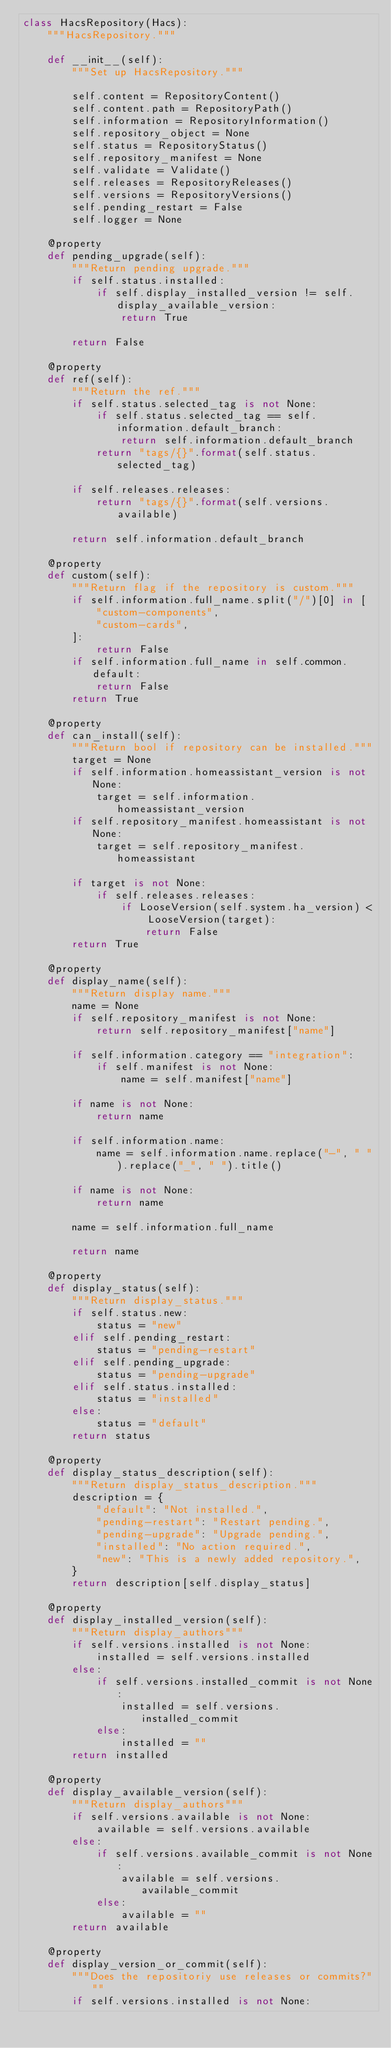Convert code to text. <code><loc_0><loc_0><loc_500><loc_500><_Python_>class HacsRepository(Hacs):
    """HacsRepository."""

    def __init__(self):
        """Set up HacsRepository."""

        self.content = RepositoryContent()
        self.content.path = RepositoryPath()
        self.information = RepositoryInformation()
        self.repository_object = None
        self.status = RepositoryStatus()
        self.repository_manifest = None
        self.validate = Validate()
        self.releases = RepositoryReleases()
        self.versions = RepositoryVersions()
        self.pending_restart = False
        self.logger = None

    @property
    def pending_upgrade(self):
        """Return pending upgrade."""
        if self.status.installed:
            if self.display_installed_version != self.display_available_version:
                return True

        return False

    @property
    def ref(self):
        """Return the ref."""
        if self.status.selected_tag is not None:
            if self.status.selected_tag == self.information.default_branch:
                return self.information.default_branch
            return "tags/{}".format(self.status.selected_tag)

        if self.releases.releases:
            return "tags/{}".format(self.versions.available)

        return self.information.default_branch

    @property
    def custom(self):
        """Return flag if the repository is custom."""
        if self.information.full_name.split("/")[0] in [
            "custom-components",
            "custom-cards",
        ]:
            return False
        if self.information.full_name in self.common.default:
            return False
        return True

    @property
    def can_install(self):
        """Return bool if repository can be installed."""
        target = None
        if self.information.homeassistant_version is not None:
            target = self.information.homeassistant_version
        if self.repository_manifest.homeassistant is not None:
            target = self.repository_manifest.homeassistant

        if target is not None:
            if self.releases.releases:
                if LooseVersion(self.system.ha_version) < LooseVersion(target):
                    return False
        return True

    @property
    def display_name(self):
        """Return display name."""
        name = None
        if self.repository_manifest is not None:
            return self.repository_manifest["name"]

        if self.information.category == "integration":
            if self.manifest is not None:
                name = self.manifest["name"]

        if name is not None:
            return name

        if self.information.name:
            name = self.information.name.replace("-", " ").replace("_", " ").title()

        if name is not None:
            return name

        name = self.information.full_name

        return name

    @property
    def display_status(self):
        """Return display_status."""
        if self.status.new:
            status = "new"
        elif self.pending_restart:
            status = "pending-restart"
        elif self.pending_upgrade:
            status = "pending-upgrade"
        elif self.status.installed:
            status = "installed"
        else:
            status = "default"
        return status

    @property
    def display_status_description(self):
        """Return display_status_description."""
        description = {
            "default": "Not installed.",
            "pending-restart": "Restart pending.",
            "pending-upgrade": "Upgrade pending.",
            "installed": "No action required.",
            "new": "This is a newly added repository.",
        }
        return description[self.display_status]

    @property
    def display_installed_version(self):
        """Return display_authors"""
        if self.versions.installed is not None:
            installed = self.versions.installed
        else:
            if self.versions.installed_commit is not None:
                installed = self.versions.installed_commit
            else:
                installed = ""
        return installed

    @property
    def display_available_version(self):
        """Return display_authors"""
        if self.versions.available is not None:
            available = self.versions.available
        else:
            if self.versions.available_commit is not None:
                available = self.versions.available_commit
            else:
                available = ""
        return available

    @property
    def display_version_or_commit(self):
        """Does the repositoriy use releases or commits?"""
        if self.versions.installed is not None:</code> 